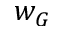Convert formula to latex. <formula><loc_0><loc_0><loc_500><loc_500>w _ { G }</formula> 